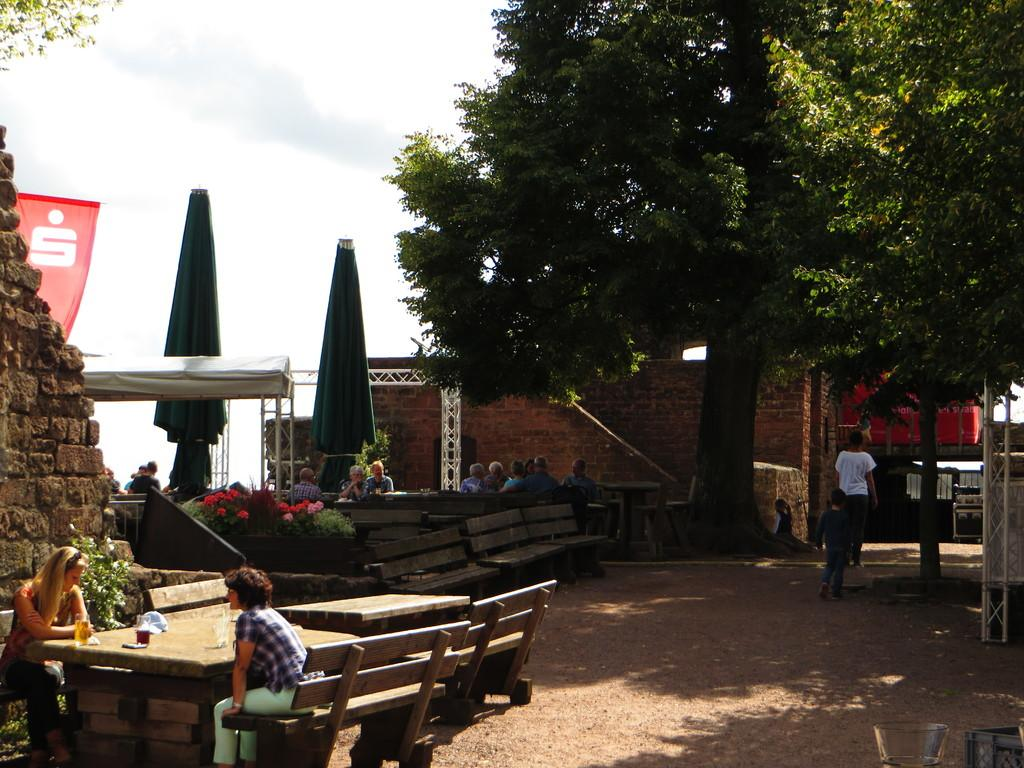What type of structure is visible in the image? There is a house in the image. What natural element is present in the image? There is a tree in the image. What are the people in the image doing? Some people are seated, while others are walking in the image. What type of furniture is present in the image? There are benches and tables in the image. What objects are used for shade in the image? There are umbrellas in the image. How would you describe the weather in the image? The sky is cloudy in the image. What type of zinc is present in the image? There is no zinc present in the image. What flavor of mint can be seen growing near the tree in the image? There is no mint present in the image. 